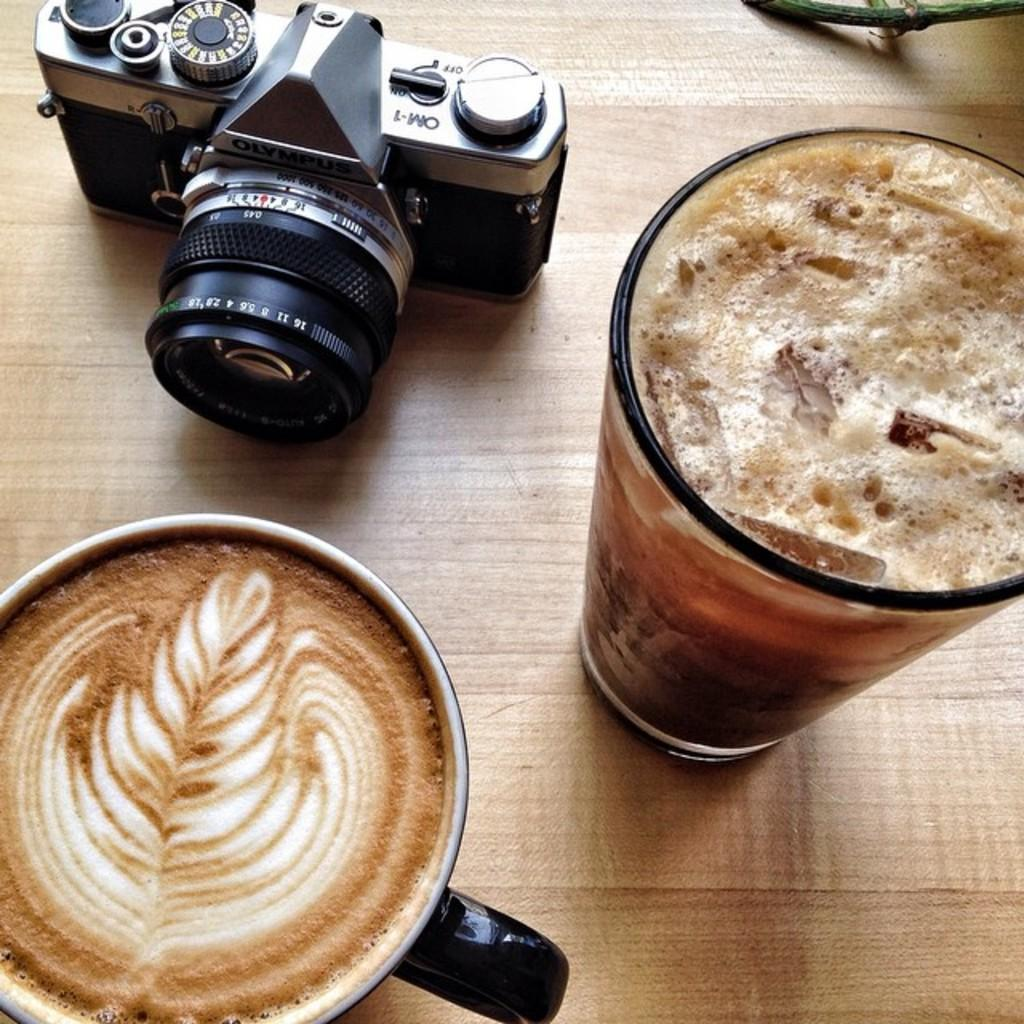What is in the cup that is visible in the image? There is a cup with coffee in the image. What is in the glass that is visible in the image? There is a glass with a drink in the image. What object can be seen on a wooden surface in the image? There is a camera on a wooden surface in the image. How many mint leaves are on the camera in the image? There are no mint leaves present in the image, as it only features a cup of coffee, a glass with a drink, and a camera on a wooden surface. 